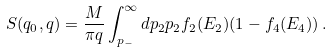<formula> <loc_0><loc_0><loc_500><loc_500>S ( q _ { 0 } , q ) = \frac { M } { \pi q } \int _ { p _ { - } } ^ { \infty } d p _ { 2 } p _ { 2 } f _ { 2 } ( E _ { 2 } ) ( 1 - f _ { 4 } ( E _ { 4 } ) ) \, . \\</formula> 